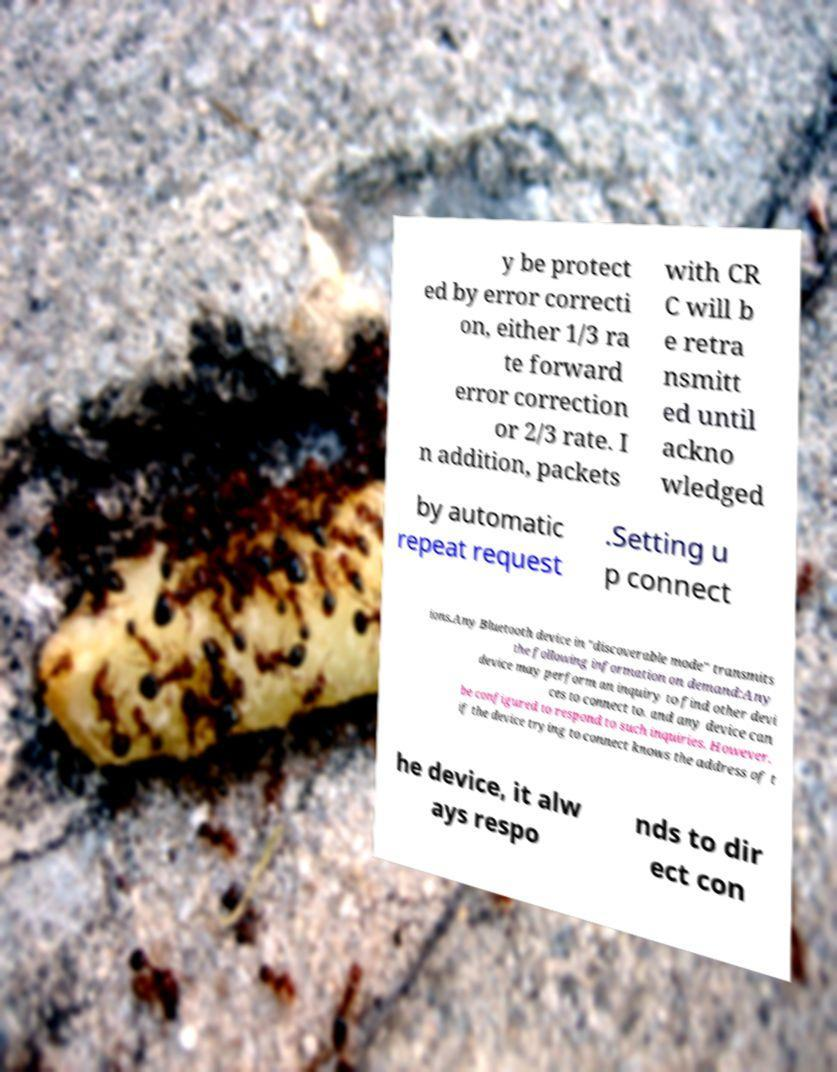I need the written content from this picture converted into text. Can you do that? y be protect ed by error correcti on, either 1/3 ra te forward error correction or 2/3 rate. I n addition, packets with CR C will b e retra nsmitt ed until ackno wledged by automatic repeat request .Setting u p connect ions.Any Bluetooth device in "discoverable mode" transmits the following information on demand:Any device may perform an inquiry to find other devi ces to connect to, and any device can be configured to respond to such inquiries. However, if the device trying to connect knows the address of t he device, it alw ays respo nds to dir ect con 